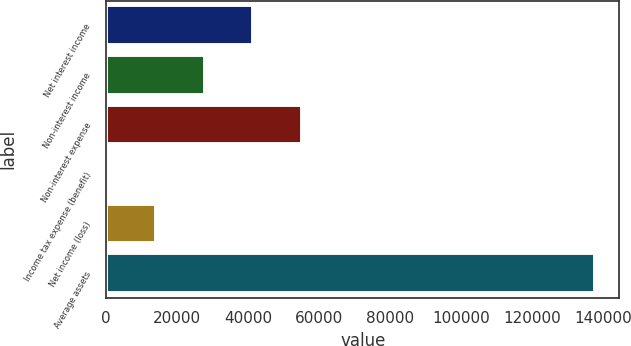Convert chart to OTSL. <chart><loc_0><loc_0><loc_500><loc_500><bar_chart><fcel>Net interest income<fcel>Non-interest income<fcel>Non-interest expense<fcel>Income tax expense (benefit)<fcel>Net income (loss)<fcel>Average assets<nl><fcel>41467.9<fcel>27725.6<fcel>55210.2<fcel>241<fcel>13983.3<fcel>137664<nl></chart> 